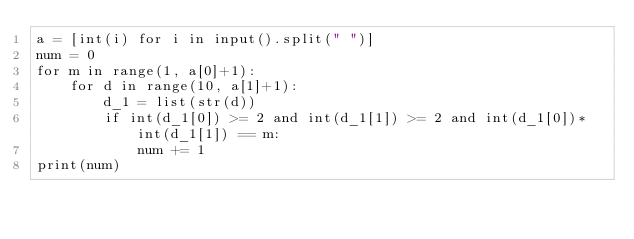Convert code to text. <code><loc_0><loc_0><loc_500><loc_500><_Python_>a = [int(i) for i in input().split(" ")]
num = 0
for m in range(1, a[0]+1):
    for d in range(10, a[1]+1):
        d_1 = list(str(d))
        if int(d_1[0]) >= 2 and int(d_1[1]) >= 2 and int(d_1[0])*int(d_1[1]) == m:
            num += 1
print(num)</code> 